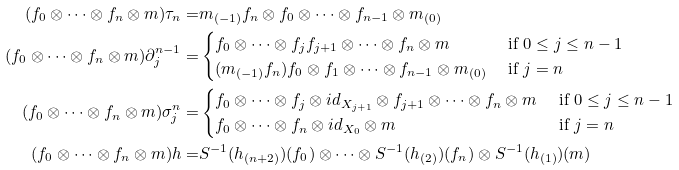<formula> <loc_0><loc_0><loc_500><loc_500>( f _ { 0 } \otimes \cdots \otimes f _ { n } \otimes m ) \tau _ { n } = & m _ { ( - 1 ) } f _ { n } \otimes f _ { 0 } \otimes \cdots \otimes f _ { n - 1 } \otimes m _ { ( 0 ) } \\ ( f _ { 0 } \otimes \cdots \otimes f _ { n } \otimes m ) \partial ^ { n - 1 } _ { j } = & \begin{cases} f _ { 0 } \otimes \cdots \otimes f _ { j } f _ { j + 1 } \otimes \cdots \otimes f _ { n } \otimes m & \text { if } 0 \leq j \leq n - 1 \\ ( m _ { ( - 1 ) } f _ { n } ) f _ { 0 } \otimes f _ { 1 } \otimes \cdots \otimes f _ { n - 1 } \otimes m _ { ( 0 ) } & \text { if } j = n \end{cases} \\ ( f _ { 0 } \otimes \cdots \otimes f _ { n } \otimes m ) \sigma ^ { n } _ { j } = & \begin{cases} f _ { 0 } \otimes \cdots \otimes f _ { j } \otimes i d _ { X _ { j + 1 } } \otimes f _ { j + 1 } \otimes \cdots \otimes f _ { n } \otimes m & \text { if } 0 \leq j \leq n - 1 \\ f _ { 0 } \otimes \cdots \otimes f _ { n } \otimes i d _ { X _ { 0 } } \otimes m & \text { if } j = n \end{cases} \\ ( f _ { 0 } \otimes \cdots \otimes f _ { n } \otimes m ) h = & S ^ { - 1 } ( h _ { ( n + 2 ) } ) ( f _ { 0 } ) \otimes \cdots \otimes S ^ { - 1 } ( h _ { ( 2 ) } ) ( f _ { n } ) \otimes S ^ { - 1 } ( h _ { ( 1 ) } ) ( m )</formula> 